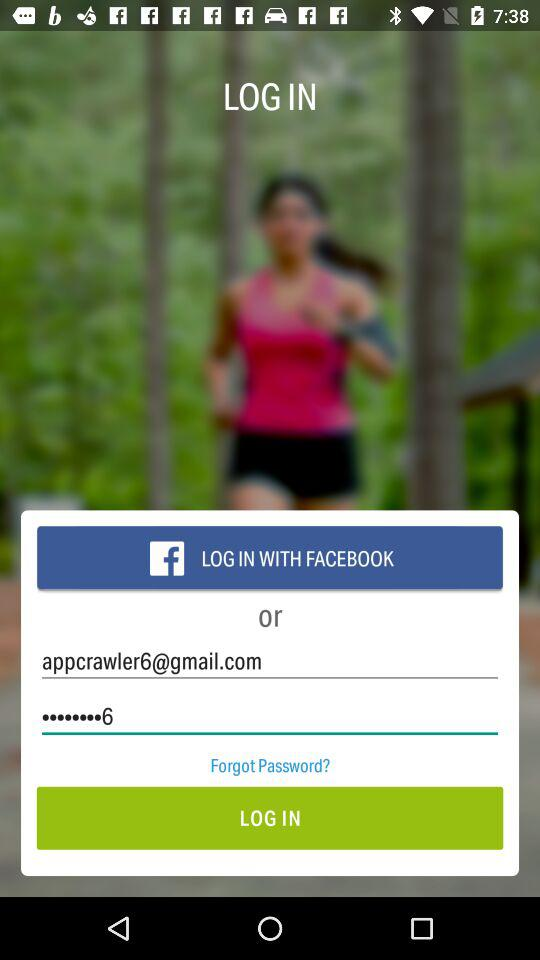How many login methods are available?
Answer the question using a single word or phrase. 2 